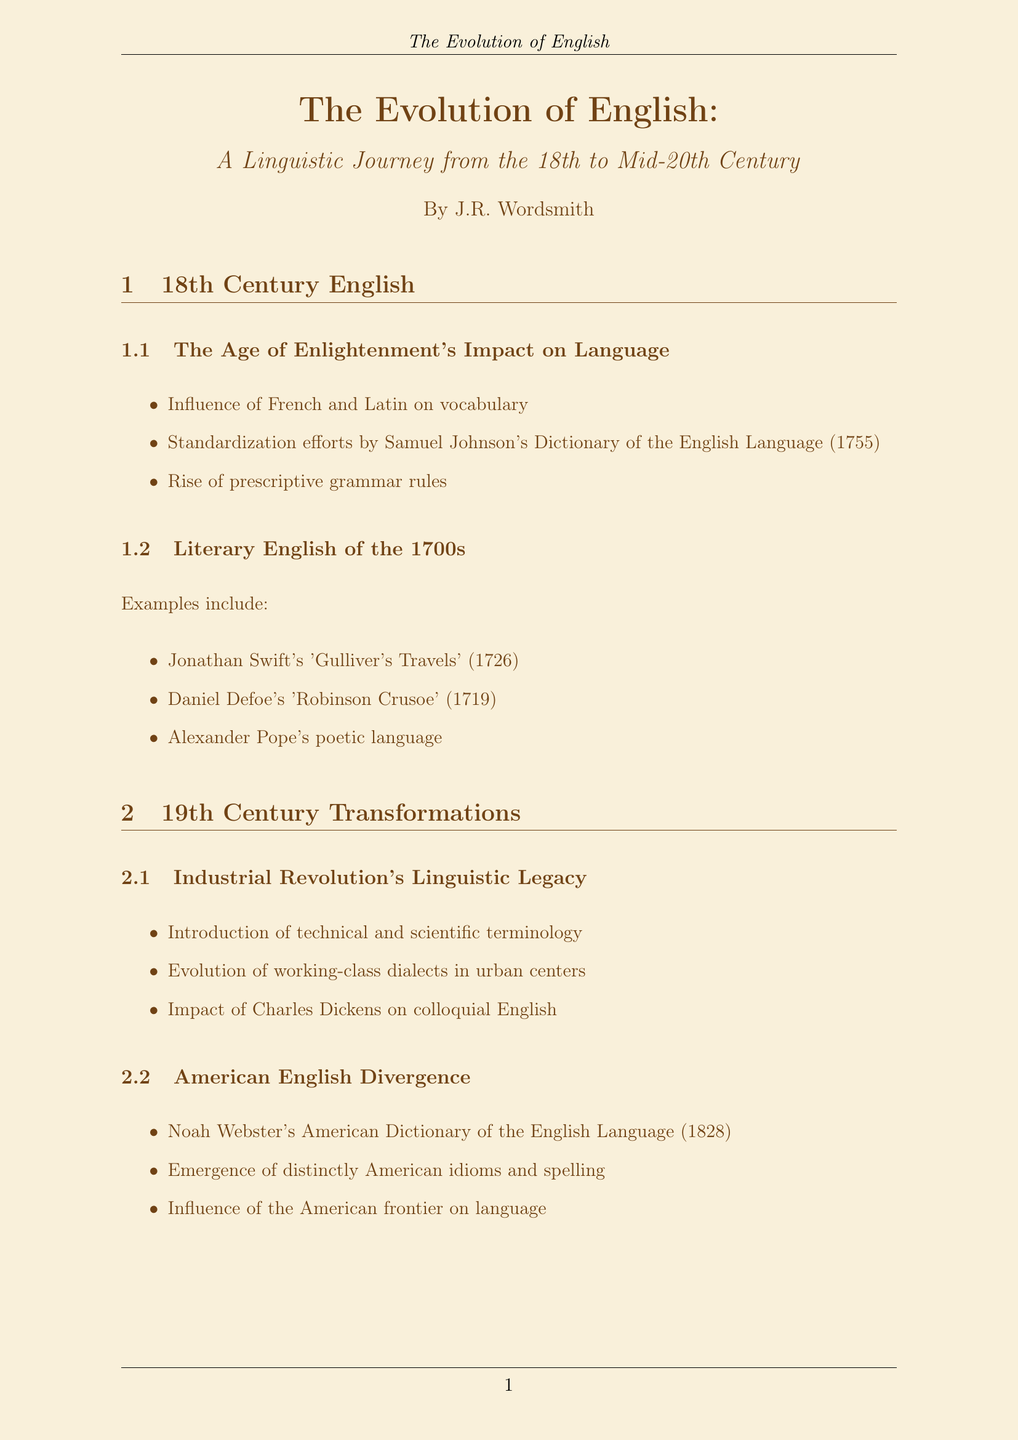What document does this report focus on? The title of the report clearly indicates its focus on the evolution of the English language over a specific time period.
Answer: The Evolution of English Who is the author of the report? The author's name is mentioned in the document's title section.
Answer: J.R. Wordsmith What year was Samuel Johnson's Dictionary published? The document states the publication year of the dictionary as part of the key points in the 18th Century English section.
Answer: 1755 Which influential writer impacted colloquial English in the 19th Century? The document specifies Charles Dickens as a significant figure in this regard.
Answer: Charles Dickens What did Noah Webster publish in 1828? The document refers to a specific dictionary that was published by Noah Webster.
Answer: American Dictionary of the English Language How did World War I influence English? The document outlines several key influences from the war, specifically mentioning military jargon.
Answer: Military jargon into everyday speech What is the Oxford English Dictionary's role? The document explains the ongoing contributions of the Oxford English Dictionary to language change documentation.
Answer: Documentation of language change What type of language emerged during the Roaring Twenties? The document discusses the types of language that diverged during this cultural period.
Answer: Jazz Age slang Which typewriter is mentioned in the writing tools? The specific typewriter used for writing is referred to in the list of writing tools.
Answer: Antique Underwood typewriter 